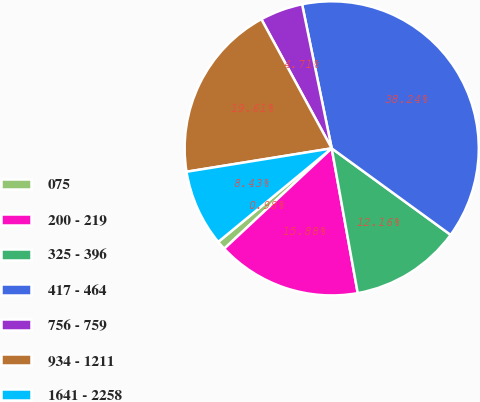Convert chart. <chart><loc_0><loc_0><loc_500><loc_500><pie_chart><fcel>075<fcel>200 - 219<fcel>325 - 396<fcel>417 - 464<fcel>756 - 759<fcel>934 - 1211<fcel>1641 - 2258<nl><fcel>0.98%<fcel>15.88%<fcel>12.16%<fcel>38.24%<fcel>4.71%<fcel>19.61%<fcel>8.43%<nl></chart> 